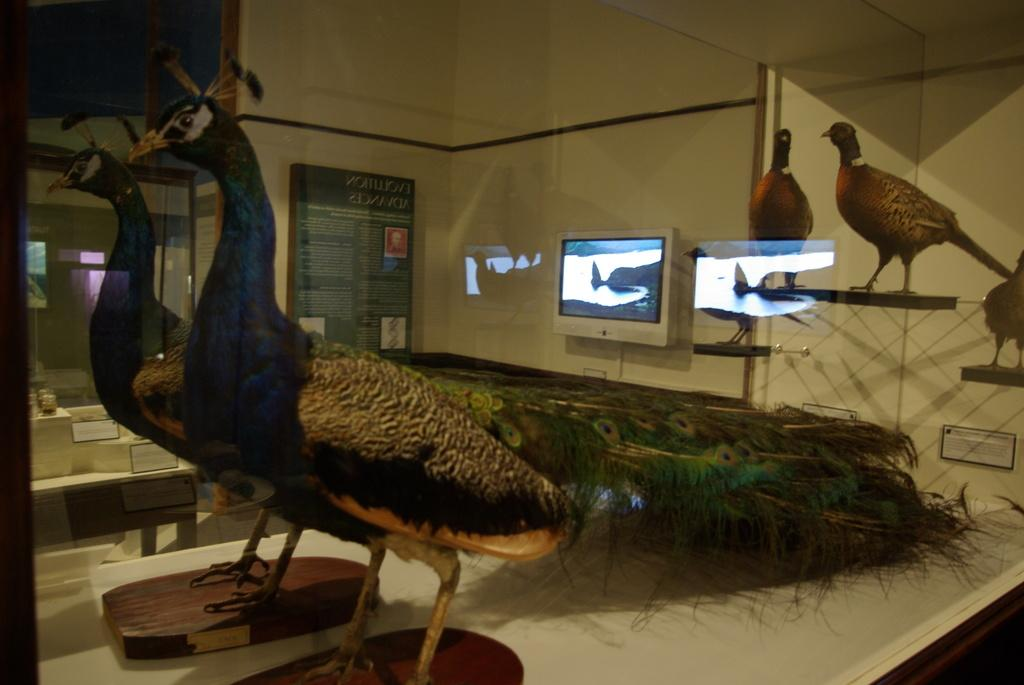What type of animals can be seen in the image? There are birds in the image. What is visible in the background of the image? There is a screen, a board, and a wall in the background of the image. Can you describe the reflection visible on the glass? The reflection of birds and the screen is visible on the glass. What type of crime is being committed in the image? There is no crime being committed in the image; it features birds and a background with a screen, board, and wall. What role does the stem play in the image? There is no stem present in the image. 